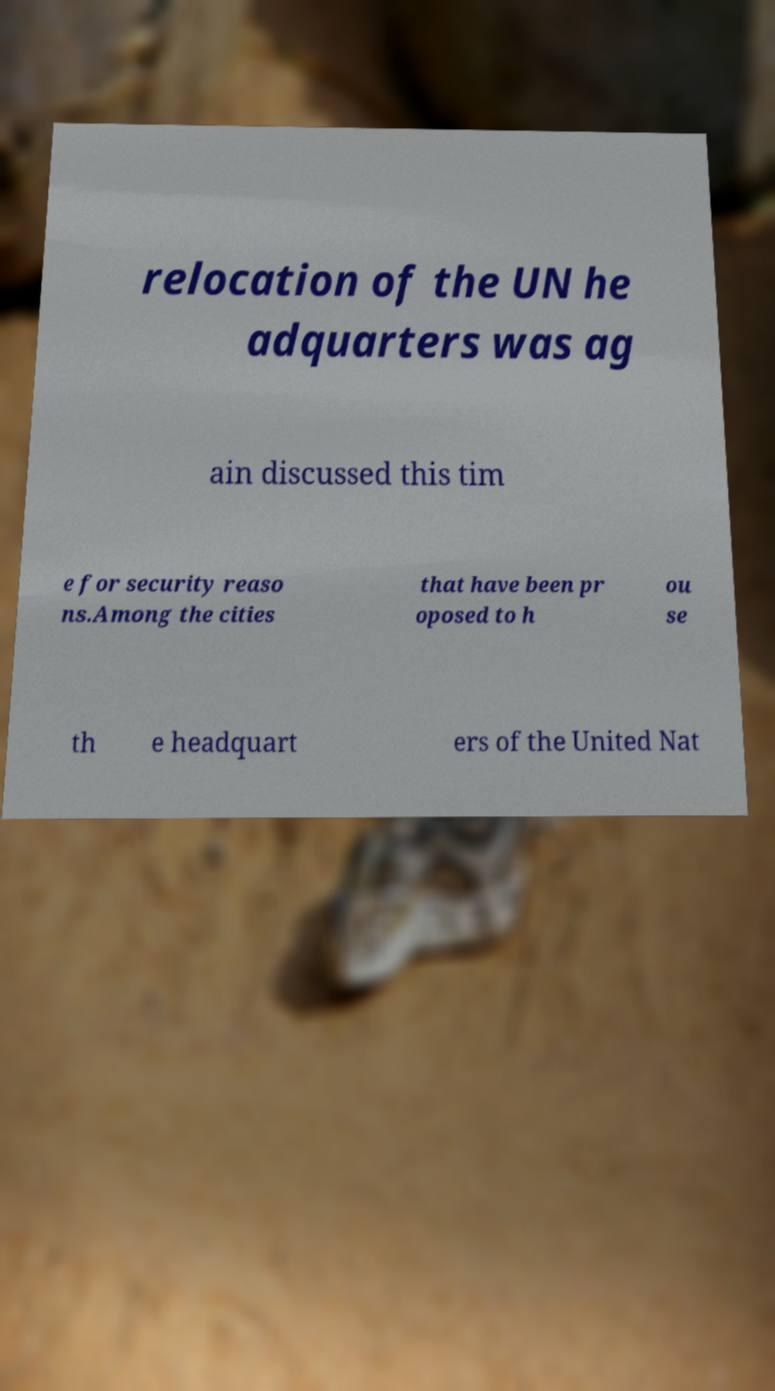There's text embedded in this image that I need extracted. Can you transcribe it verbatim? relocation of the UN he adquarters was ag ain discussed this tim e for security reaso ns.Among the cities that have been pr oposed to h ou se th e headquart ers of the United Nat 